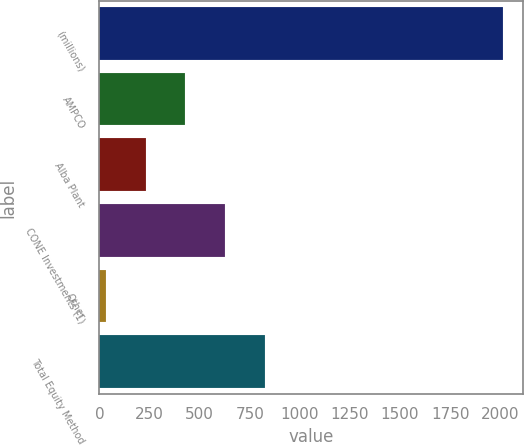Convert chart to OTSL. <chart><loc_0><loc_0><loc_500><loc_500><bar_chart><fcel>(millions)<fcel>AMPCO<fcel>Alba Plant<fcel>CONE Investments (1)<fcel>Other<fcel>Total Equity Method<nl><fcel>2015<fcel>428.6<fcel>230.3<fcel>626.9<fcel>32<fcel>825.2<nl></chart> 